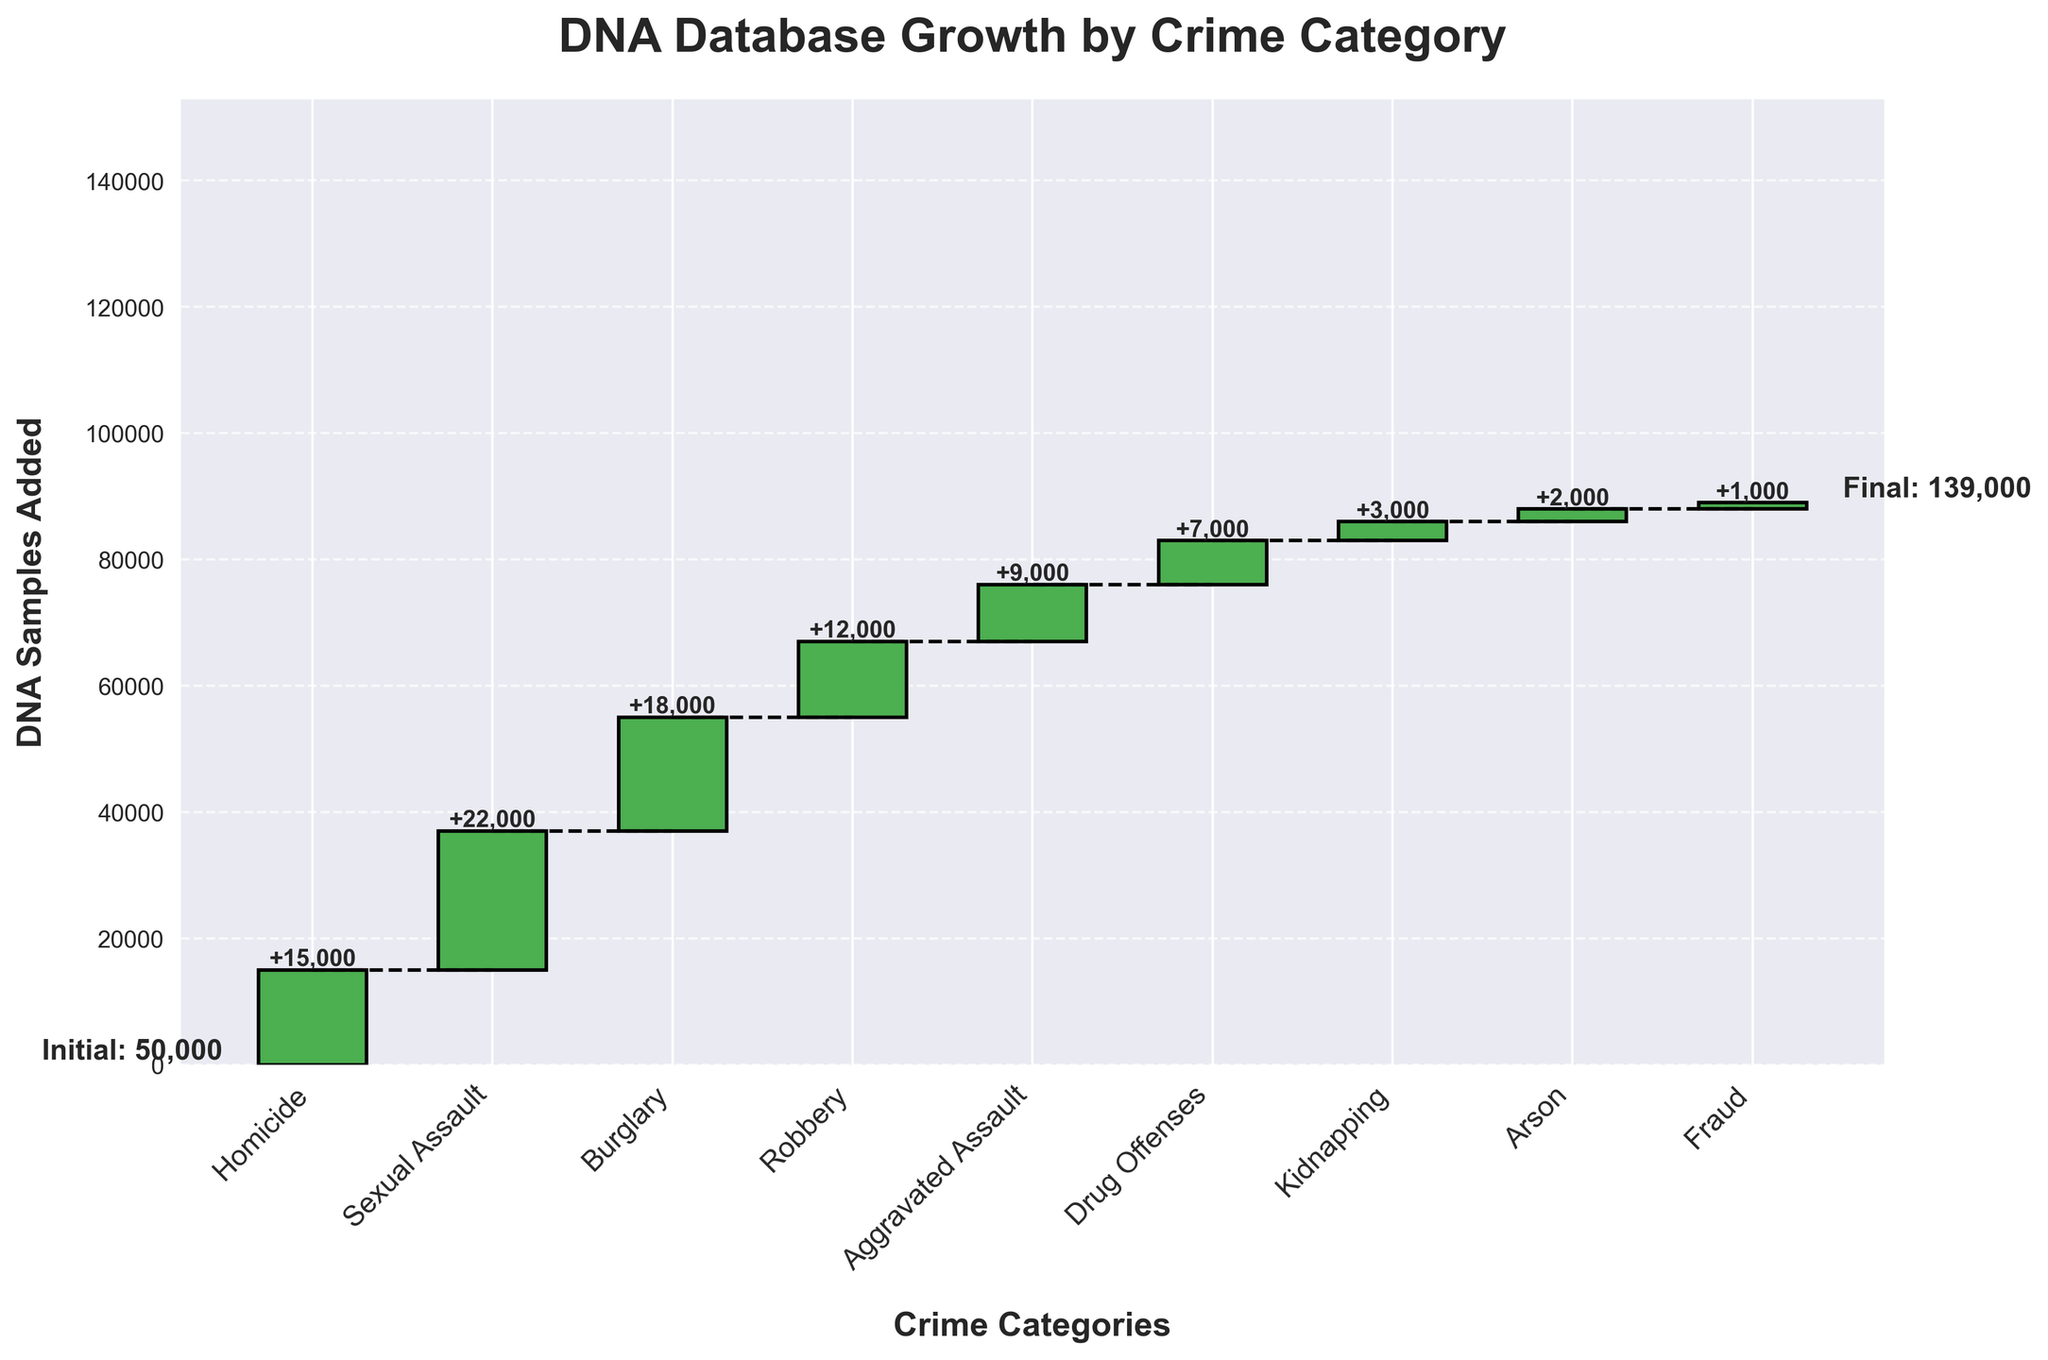what is the title of the chart? The title of the chart is at the top of the figure. It's clearly written in a bold and large font for better visibility.
Answer: DNA Database Growth by Crime Category how many crime categories are displayed in the chart? Count the number of distinct bars representing different crime categories. There are bars for Homicide, Sexual Assault, Burglary, Robbery, Aggravated Assault, Drug Offenses, Kidnapping, Arson, and Fraud.
Answer: 9 what is the height of the bar representing Sexual Assault cases? The height of the bar represents the number of DNA samples added for each crime category. For Sexual Assault, the value is written on top of the bar as 22000.
Answer: 22000 which crime category contributed the fewest DNA samples? Compare the heights of all bars to find the smallest one. The bar with the smallest height and value on top is Fraud, with 1000 DNA samples added.
Answer: Fraud how many DNA samples were added after considering both Burglary and Robbery cases? Add the DNA samples contributed by the Burglary and Robbery categories. Burglary added 18000 and Robbery added 12000. So, 18000 + 12000 = 30000.
Answer: 30000 what's the difference in DNA samples added between Homicide and Aggravated Assault cases? Subtract the number of DNA samples added for Aggravated Assault from those added for Homicide. So, 15000 - 9000 = 6000.
Answer: 6000 which crime category contributed more DNA samples: Arson or Kidnapping? Compare the heights of the bars for Arson and Kidnapping. The value on top of the Kidnapping bar is 3000, and for Arson, it's 2000. Kidnapping contributed more DNA samples.
Answer: Kidnapping how many DNA samples were in the initial database? The initial number of DNA samples is written on the figure, usually at the start or bottom of the chart. It's labeled as "Initial Database" with a value of 50000.
Answer: 50000 what is the final total of DNA samples in the database? The final number of DNA samples is written at the end of the chart. It's labeled as "Current Database Total" with a value of 139000.
Answer: 139000 what is the cumulative number of DNA samples added from all crime categories? The cumulative number of DNA samples added is the sum of DNA samples from all bars. The chart shows this sum as 139000 - 50000 = 89000, which is the total number added.
Answer: 89000 